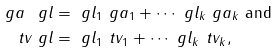<formula> <loc_0><loc_0><loc_500><loc_500>\ g a _ { \ } g l & = \ g l _ { 1 } \ g a _ { 1 } + \cdots \ g l _ { k } \ g a _ { k } \text { and } \\ \ t v _ { \ } g l & = \ g l _ { 1 } \ t v _ { 1 } + \cdots \ g l _ { k } \ t v _ { k } ,</formula> 